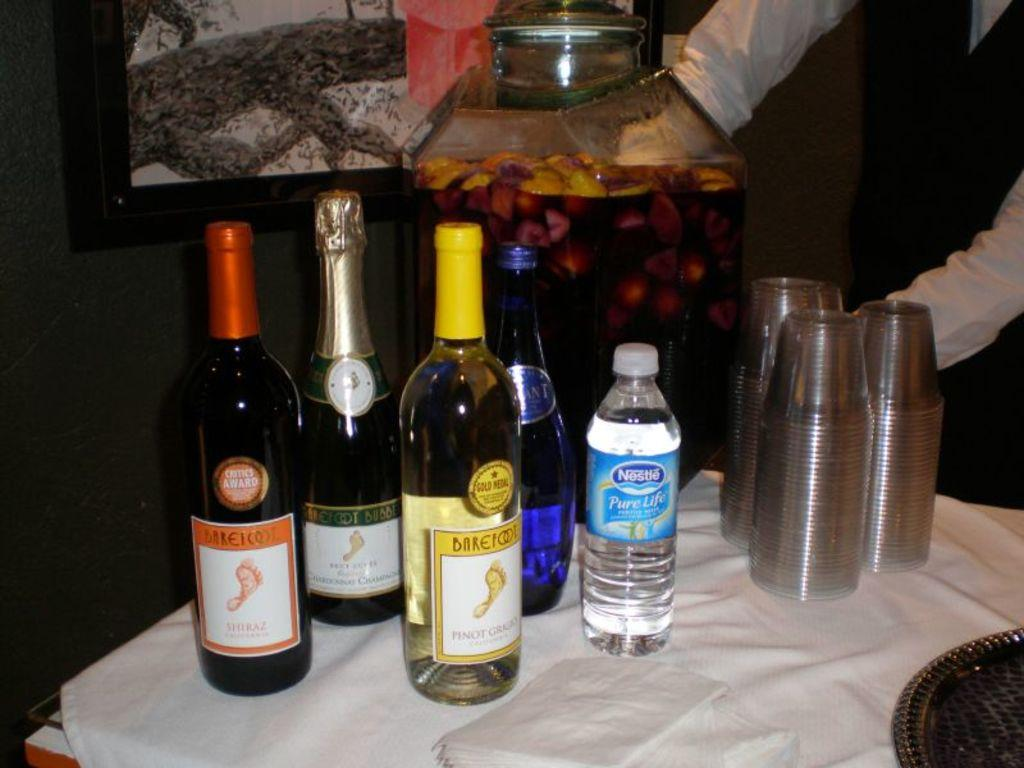<image>
Provide a brief description of the given image. Three bottles of Barefoot brand wine sit near a Nestle bottle of water. 